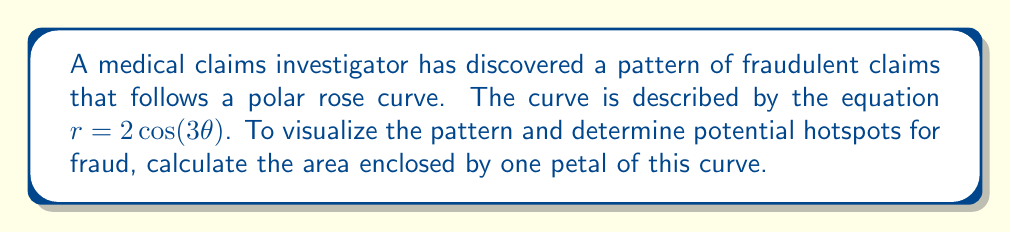Provide a solution to this math problem. To solve this problem, we'll follow these steps:

1) The area of a polar rose curve with $n$ petals is given by the formula:

   $A = \frac{a^2}{2} \int_0^{\frac{2\pi}{n}} \sin^2(n\theta) d\theta$

   where $a$ is the amplitude and $n$ is the number of petals.

2) In our case, $r = 2\cos(3\theta)$, so $a = 2$ and $n = 3$.

3) Substituting these values into the formula:

   $A = \frac{2^2}{2} \int_0^{\frac{2\pi}{3}} \sin^2(3\theta) d\theta = 2 \int_0^{\frac{2\pi}{3}} \sin^2(3\theta) d\theta$

4) To evaluate this integral, we can use the trigonometric identity:

   $\sin^2(x) = \frac{1 - \cos(2x)}{2}$

5) Applying this to our integral:

   $A = 2 \int_0^{\frac{2\pi}{3}} \frac{1 - \cos(6\theta)}{2} d\theta = \int_0^{\frac{2\pi}{3}} (1 - \cos(6\theta)) d\theta$

6) Evaluating the integral:

   $A = [\theta - \frac{1}{6}\sin(6\theta)]_0^{\frac{2\pi}{3}}$

7) Substituting the limits:

   $A = (\frac{2\pi}{3} - \frac{1}{6}\sin(4\pi)) - (0 - \frac{1}{6}\sin(0)) = \frac{2\pi}{3}$

Therefore, the area enclosed by one petal of the curve is $\frac{2\pi}{3}$ square units.
Answer: $\frac{2\pi}{3}$ square units 